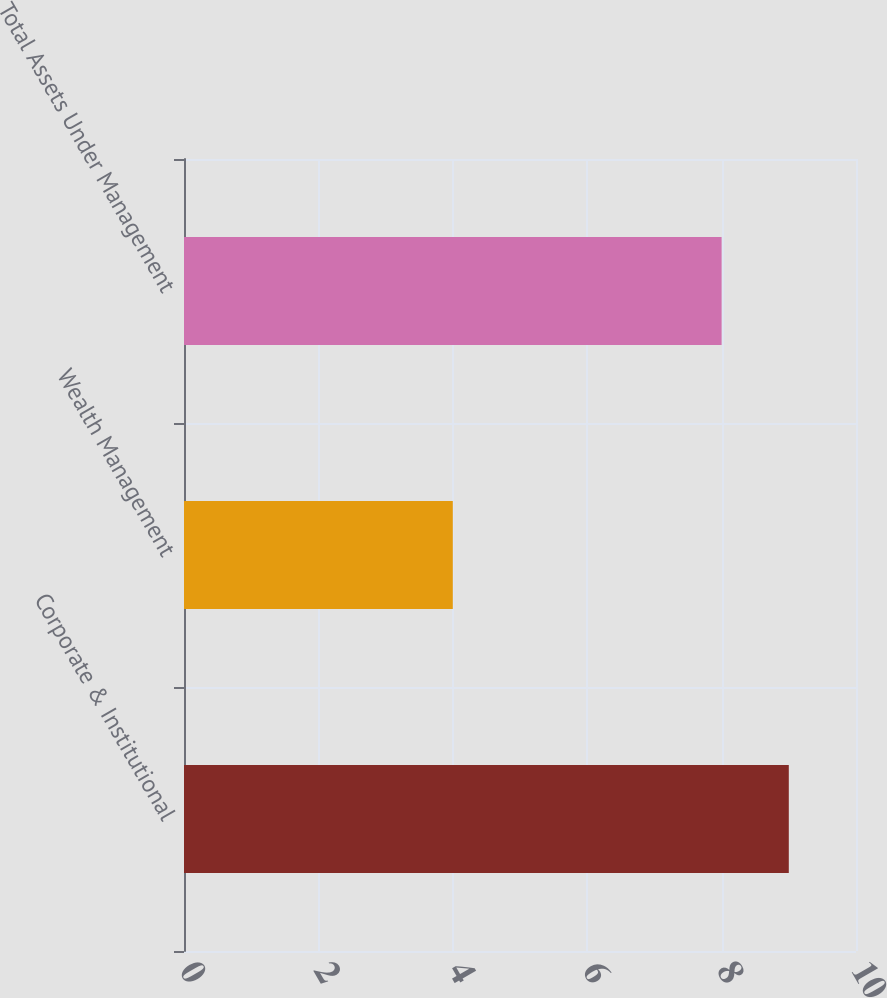<chart> <loc_0><loc_0><loc_500><loc_500><bar_chart><fcel>Corporate & Institutional<fcel>Wealth Management<fcel>Total Assets Under Management<nl><fcel>9<fcel>4<fcel>8<nl></chart> 